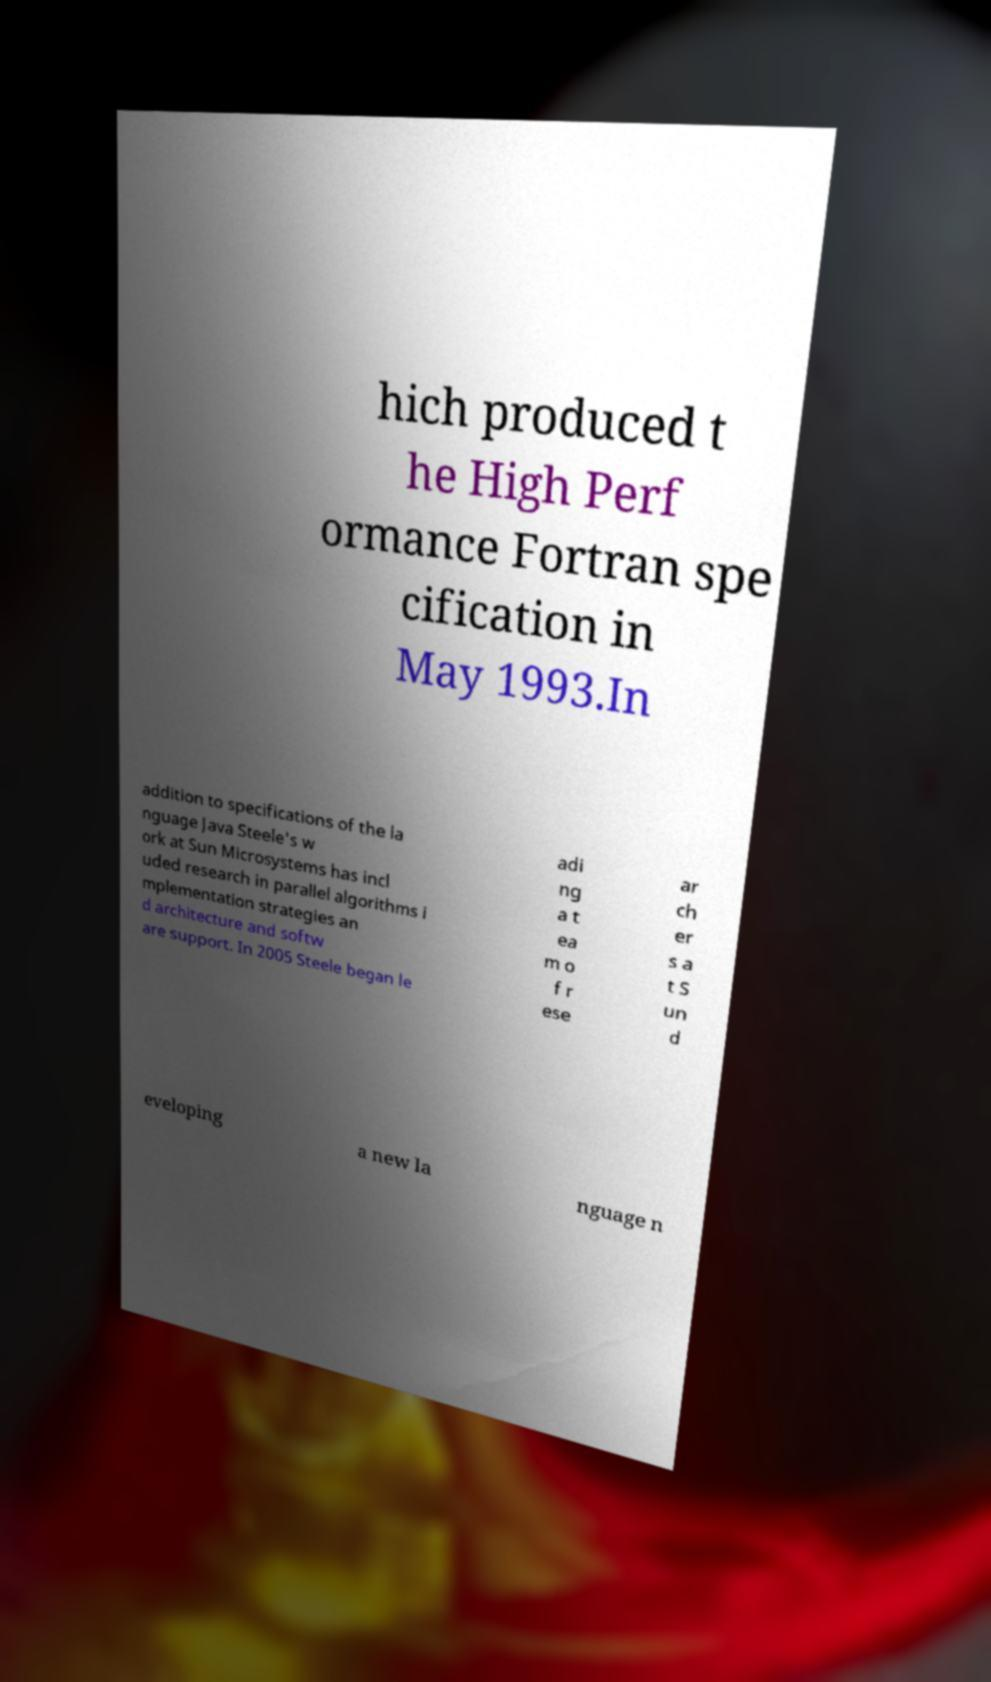Can you read and provide the text displayed in the image?This photo seems to have some interesting text. Can you extract and type it out for me? hich produced t he High Perf ormance Fortran spe cification in May 1993.In addition to specifications of the la nguage Java Steele's w ork at Sun Microsystems has incl uded research in parallel algorithms i mplementation strategies an d architecture and softw are support. In 2005 Steele began le adi ng a t ea m o f r ese ar ch er s a t S un d eveloping a new la nguage n 